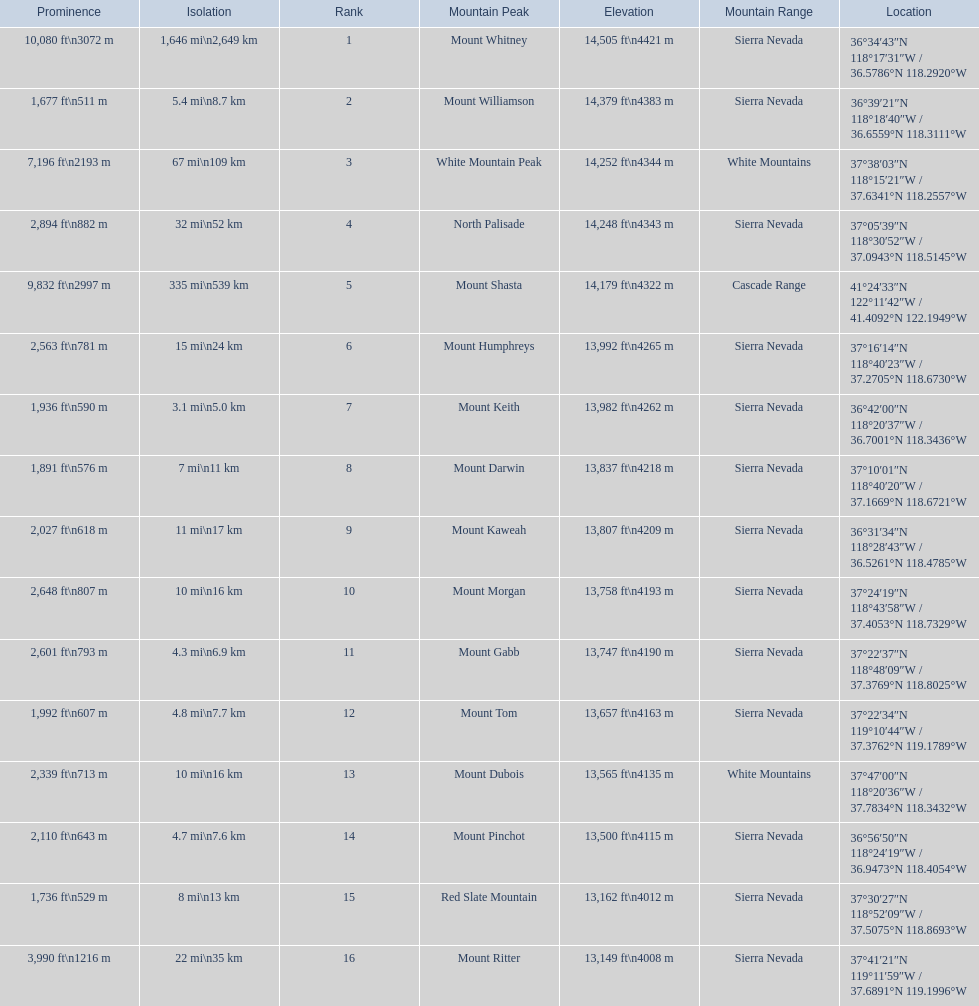What are the heights of the peaks? 14,505 ft\n4421 m, 14,379 ft\n4383 m, 14,252 ft\n4344 m, 14,248 ft\n4343 m, 14,179 ft\n4322 m, 13,992 ft\n4265 m, 13,982 ft\n4262 m, 13,837 ft\n4218 m, 13,807 ft\n4209 m, 13,758 ft\n4193 m, 13,747 ft\n4190 m, 13,657 ft\n4163 m, 13,565 ft\n4135 m, 13,500 ft\n4115 m, 13,162 ft\n4012 m, 13,149 ft\n4008 m. Which of these heights is tallest? 14,505 ft\n4421 m. What peak is 14,505 feet? Mount Whitney. 